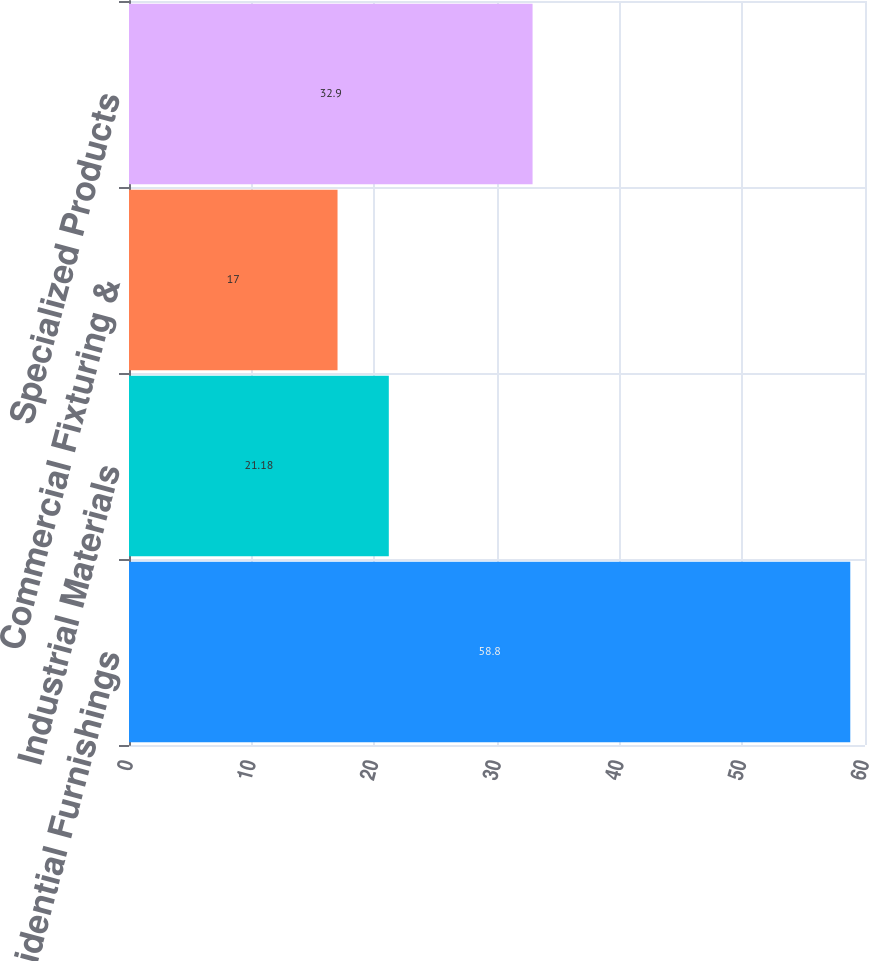<chart> <loc_0><loc_0><loc_500><loc_500><bar_chart><fcel>Residential Furnishings<fcel>Industrial Materials<fcel>Commercial Fixturing &<fcel>Specialized Products<nl><fcel>58.8<fcel>21.18<fcel>17<fcel>32.9<nl></chart> 